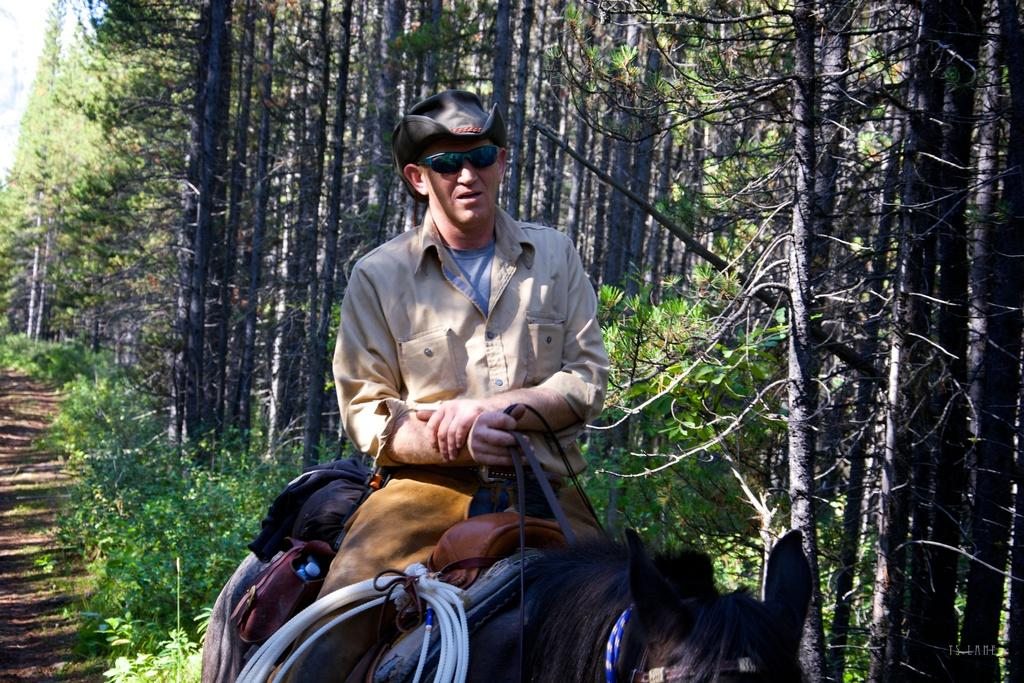What is the man in the image wearing on his head? The man is wearing a cap in the image. What protective gear is the man wearing in the image? The man is wearing goggles in the image. What is the man holding in the image? The man is holding bags in the image. What can be seen on the animal in the image? There are pipes on an animal in the image. What type of natural environment is visible in the background of the image? There are trees and a path visible in the background of the image. How does the man's feeling about his partner affect the nerve of the animal in the image? There is no mention of the man's feelings or a partner in the image, and the animal's nerve is not a factor in the image. 